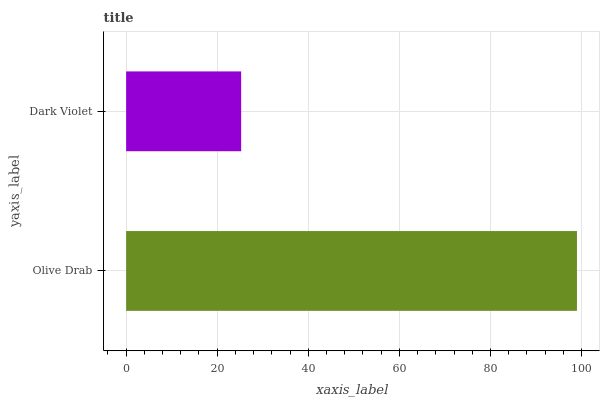Is Dark Violet the minimum?
Answer yes or no. Yes. Is Olive Drab the maximum?
Answer yes or no. Yes. Is Dark Violet the maximum?
Answer yes or no. No. Is Olive Drab greater than Dark Violet?
Answer yes or no. Yes. Is Dark Violet less than Olive Drab?
Answer yes or no. Yes. Is Dark Violet greater than Olive Drab?
Answer yes or no. No. Is Olive Drab less than Dark Violet?
Answer yes or no. No. Is Olive Drab the high median?
Answer yes or no. Yes. Is Dark Violet the low median?
Answer yes or no. Yes. Is Dark Violet the high median?
Answer yes or no. No. Is Olive Drab the low median?
Answer yes or no. No. 